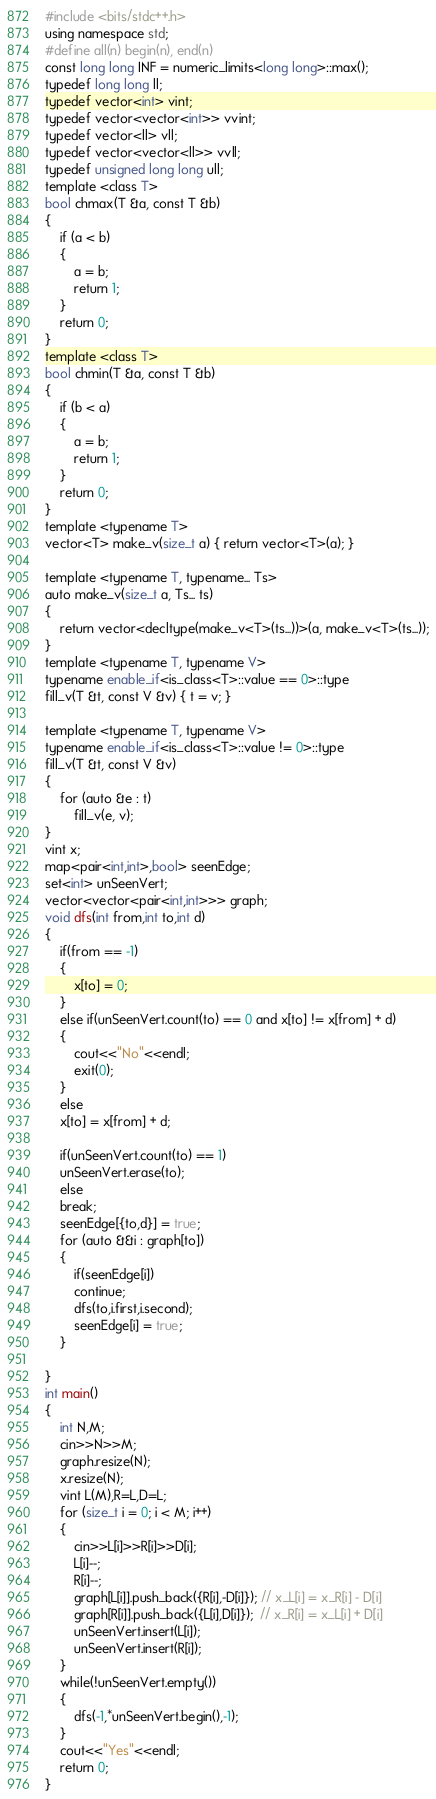Convert code to text. <code><loc_0><loc_0><loc_500><loc_500><_C++_>#include <bits/stdc++.h>
using namespace std;
#define all(n) begin(n), end(n)
const long long INF = numeric_limits<long long>::max();
typedef long long ll;
typedef vector<int> vint;
typedef vector<vector<int>> vvint;
typedef vector<ll> vll;
typedef vector<vector<ll>> vvll;
typedef unsigned long long ull;
template <class T>
bool chmax(T &a, const T &b)
{
    if (a < b)
    {
        a = b;
        return 1;
    }
    return 0;
}
template <class T>
bool chmin(T &a, const T &b)
{
    if (b < a)
    {
        a = b;
        return 1;
    }
    return 0;
}
template <typename T>
vector<T> make_v(size_t a) { return vector<T>(a); }

template <typename T, typename... Ts>
auto make_v(size_t a, Ts... ts)
{
    return vector<decltype(make_v<T>(ts...))>(a, make_v<T>(ts...));
}
template <typename T, typename V>
typename enable_if<is_class<T>::value == 0>::type
fill_v(T &t, const V &v) { t = v; }

template <typename T, typename V>
typename enable_if<is_class<T>::value != 0>::type
fill_v(T &t, const V &v)
{
    for (auto &e : t)
        fill_v(e, v);
}
vint x;
map<pair<int,int>,bool> seenEdge;
set<int> unSeenVert;
vector<vector<pair<int,int>>> graph;
void dfs(int from,int to,int d)
{
    if(from == -1)
    {
        x[to] = 0;
    }
    else if(unSeenVert.count(to) == 0 and x[to] != x[from] + d)
    {
        cout<<"No"<<endl;
        exit(0);
    }
    else
    x[to] = x[from] + d;

    if(unSeenVert.count(to) == 1)
    unSeenVert.erase(to);
    else
    break;
    seenEdge[{to,d}] = true;
    for (auto &&i : graph[to])
    {
        if(seenEdge[i])
        continue;
        dfs(to,i.first,i.second);
        seenEdge[i] = true;
    }
    
}
int main()
{
    int N,M;
    cin>>N>>M;
    graph.resize(N);
    x.resize(N);
    vint L(M),R=L,D=L;
    for (size_t i = 0; i < M; i++)
    {
        cin>>L[i]>>R[i]>>D[i];
        L[i]--;
        R[i]--;
        graph[L[i]].push_back({R[i],-D[i]}); // x_L[i] = x_R[i] - D[i]
        graph[R[i]].push_back({L[i],D[i]});  // x_R[i] = x_L[i] + D[i]
        unSeenVert.insert(L[i]);
        unSeenVert.insert(R[i]);
    }
    while(!unSeenVert.empty())
    {
        dfs(-1,*unSeenVert.begin(),-1);
    }
    cout<<"Yes"<<endl;
    return 0;
}</code> 